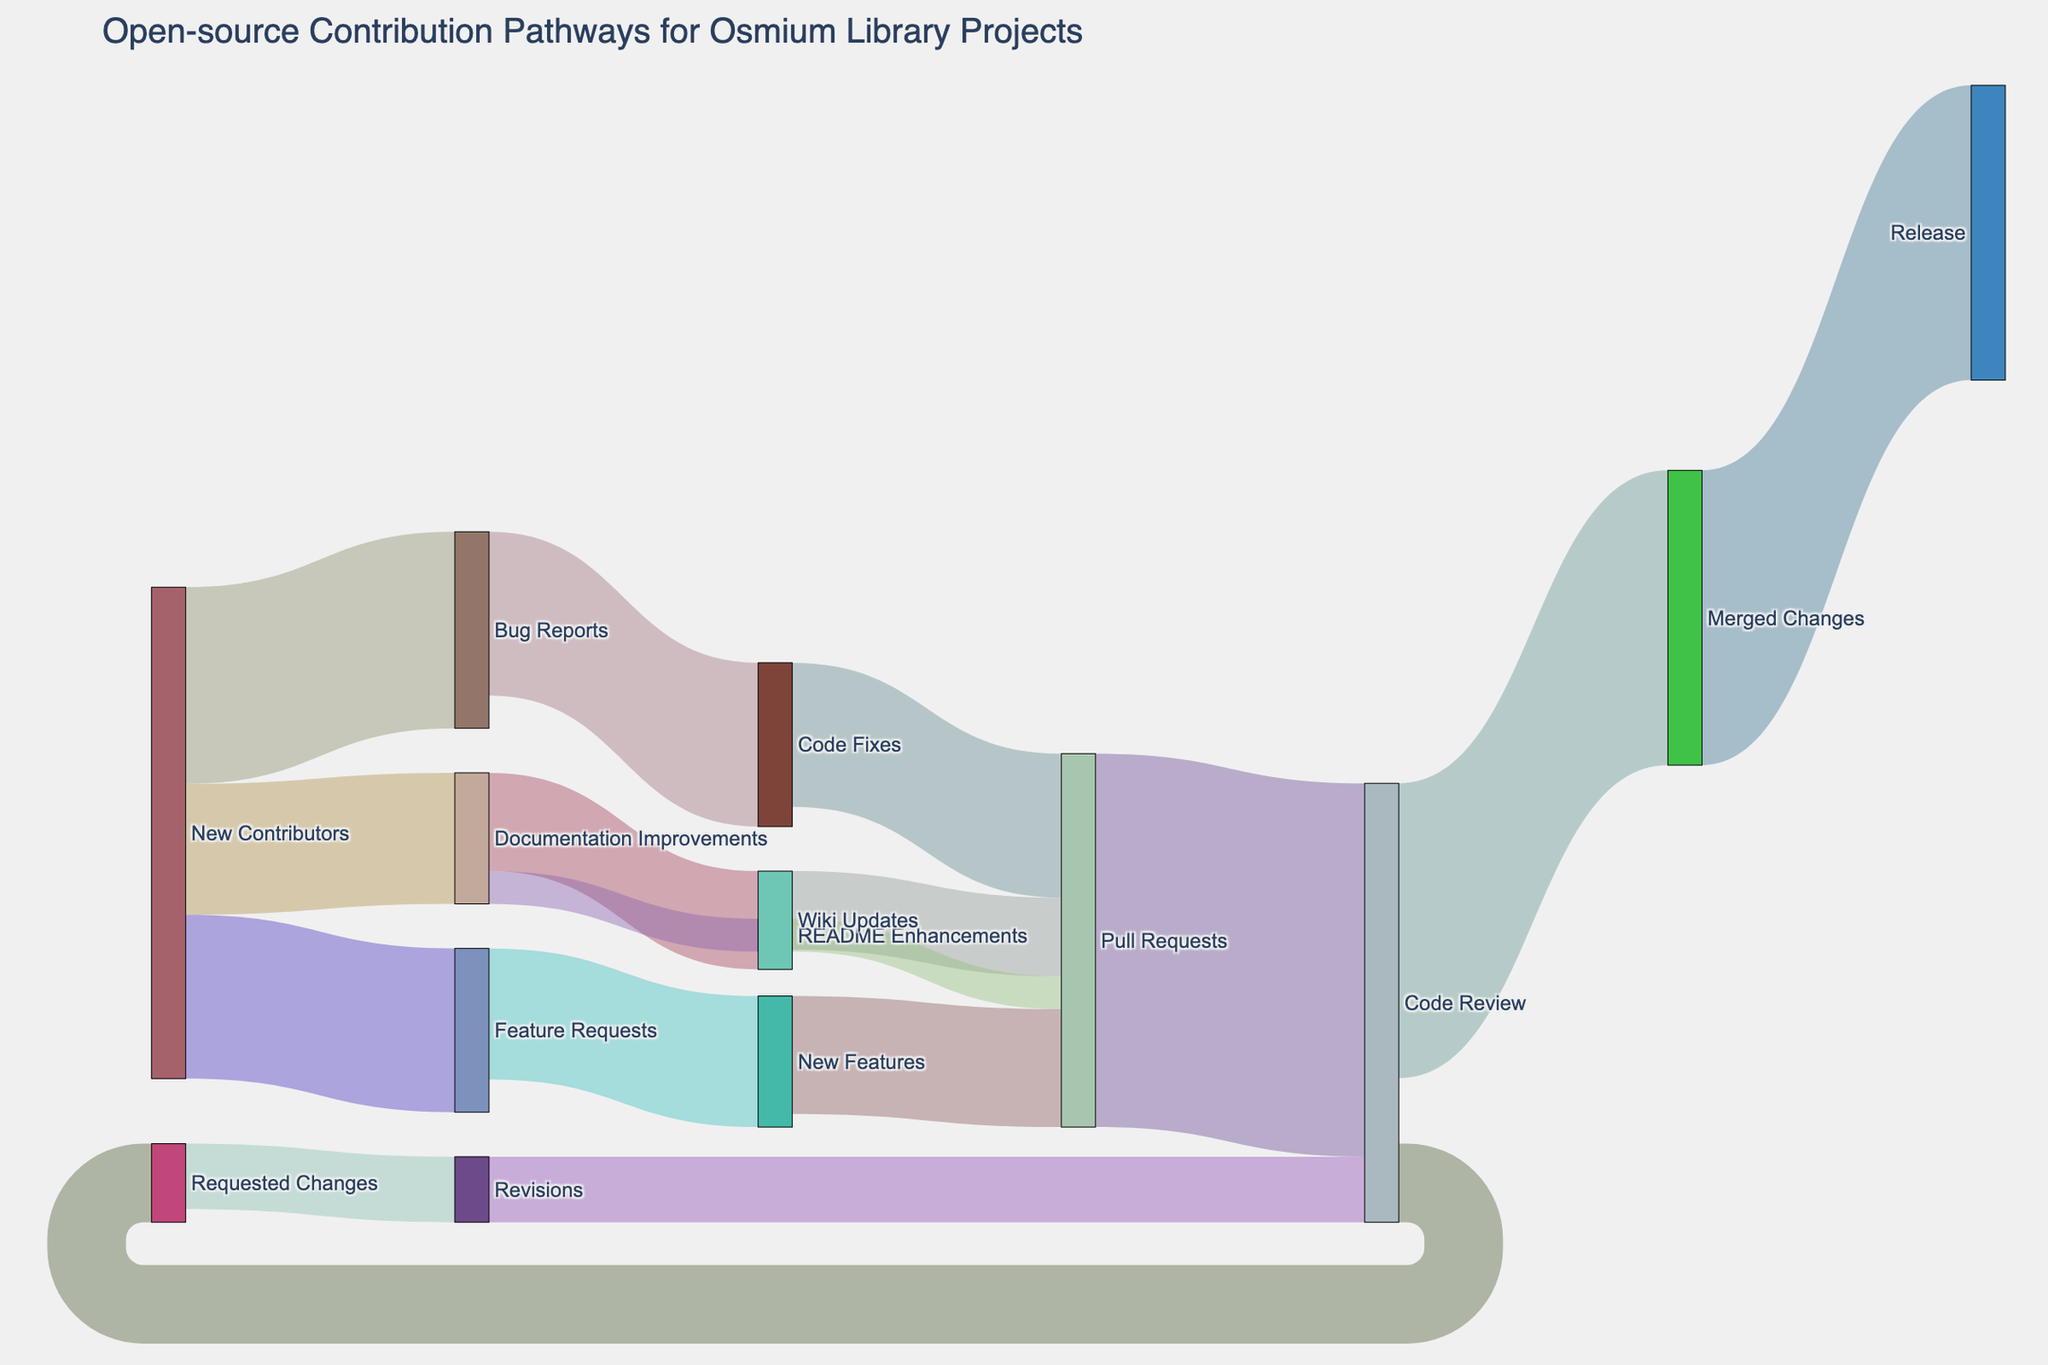What's the title of the figure? The title of the figure is usually displayed at the top. In this case, from the code provided, we see it is set explicitly.
Answer: "Open-source Contribution Pathways for Osmium Library Projects" How many pathways lead to "Pull Requests"? Pathways leading to "Pull Requests" can be identified by tracing the links connecting to it. These include contributions from "Code Fixes", "New Features", "Wiki Updates", and "README Enhancements". Hence, there are 4 pathways.
Answer: 4 What is the total number of contributions at the "Code Review" stage? Sum the values of links leading to "Code Review" from "Pull Requests" and "Revisions", which are 57 and 10 respectively. Therefore, the total is 57 + 10 = 67.
Answer: 67 Which stage do all "Merged Changes" go directly into? Observe the pathway leading from "Merged Changes", which goes directly to "Release".
Answer: "Release" What is the difference in the number of contributions between "Feature Requests" leading to "New Features" and "Bug Reports" leading to "Code Fixes"? "Feature Requests" to "New Features" has 20 contributions while "Bug Reports" to "Code Fixes" has 25. The difference is 25 - 20 = 5.
Answer: 5 How many unique nodes are present in the diagram? Count all distinct elements in both 'source' and 'target' columns. These nodes include "New Contributors", "Bug Reports", "Feature Requests", "Documentation Improvements", "Code Fixes", "New Features", "Wiki Updates", "README Enhancements", "Pull Requests", "Code Review", "Merged Changes", "Requested Changes", "Revisions", and "Release". Therefore, there are 14 unique nodes.
Answer: 14 Which stage has the smallest number of contributions flowing into it, and what is that number? Trace the stage with the least cumulative link values directed into it. "Revisions" receives the smallest value, totaling 10 contributions.
Answer: "Revisions" with 10 How many contribution pathways originate from "Documentation Improvements"? Identify all pathways starting from "Documentation Improvements". These pathways are directed to "Wiki Updates" and "README Enhancements", summing up to 2 pathways.
Answer: 2 What is the overall sum of contributions initiated by "New Contributors"? Sum up the values from all links originating from "New Contributors", which are 30 (Bug Reports) + 25 (Feature Requests) + 20 (Documentation Improvements). Thus, the total is 30 + 25 + 20 = 75.
Answer: 75 